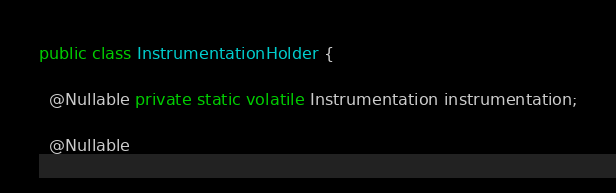<code> <loc_0><loc_0><loc_500><loc_500><_Java_>public class InstrumentationHolder {

  @Nullable private static volatile Instrumentation instrumentation;

  @Nullable</code> 